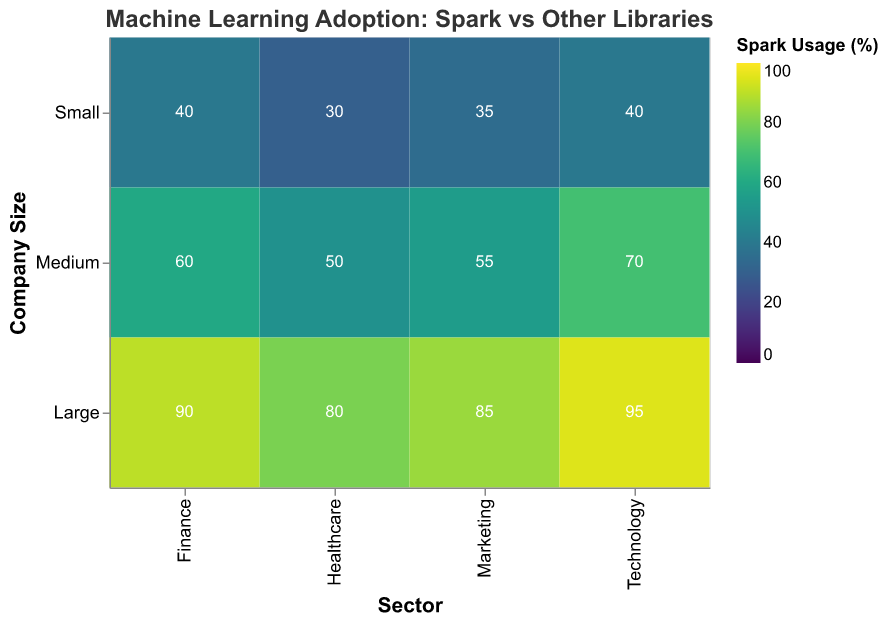What is the total Spark usage percentage for large companies in the finance sector? First, locate the "Large" company size row and the "Finance" sector column. From the heatmap, the Spark Usage for this intersection is 90%.
Answer: 90 How does the Spark usage in the healthcare sector vary by company size? The Spark Usage percentages for the healthcare sector are: 30% (Small), 50% (Medium), and 80% (Large).
Answer: 30% (Small), 50% (Medium), 80% (Large) Which sector has the highest Spark usage in medium-sized companies? Refer to the medium-sized row. Compare Spark Usage across Healthcare (50%), Finance (60%), Marketing (55%), Technology (70%). The highest is Technology.
Answer: Technology What is the difference in Spark usage between large and small companies in the technology sector? Spark Usage in the technology sector for large companies is 95%, and for small companies, it is 40%. The difference is 95% - 40% = 55%.
Answer: 55% What is the average Spark usage percentage for all sectors across small companies? Spark Usage for small companies: Healthcare (30%), Finance (40%), Marketing (35%), Technology (40%). Average = (30 + 40 + 35 + 40) / 4 = 36.25%.
Answer: 36.25% Is Spark usage generally higher in larger companies across all sectors? Compare Spark Usage percentages across all sectors for Small, Medium, and Large companies. Larger companies consistently show higher Spark usage than Small and Medium. Example: Finance sector shows 40% (Small), 60% (Medium), 90% (Large).
Answer: Yes Which sector with medium-sized companies has the lowest usage of other ML libraries? Compare Other ML Libraries Usage for medium-sized companies in Healthcare (25%), Finance (20%), Marketing (30%), Technology (20%). The lowest is Finance and Technology, which are both 20%.
Answer: Finance and Technology Does the marketing sector have greater Spark usage than other ML libraries usage for large companies? In the Marketing sector for large companies, Spark Usage is 85% while Other ML Libraries Usage is 20%. Thus, Spark usage is greater.
Answer: Yes What is the total Spark usage for companies of all sizes in the finance sector? Sum the Spark usage for Finance across all company sizes: 40% (Small) + 60% (Medium) + 90% (Large) = 190%.
Answer: 190 Which sector has the closest Spark Usage between medium and large companies? Compare Spark Usage percentages between Medium and Large for: Healthcare (50% vs 80%), Finance (60% vs 90%), Marketing (55% vs 85%), Technology (70% vs 95%). The smallest difference is in Technology (25%).
Answer: Technology 